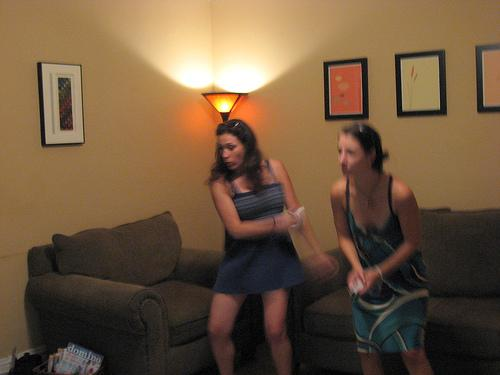Mention an accessory worn by the woman on the right and describe its placement on her. The woman on the right is wearing a bracelet on her arm. What kind of gaming device is being used by one of the women in the image? A woman is using a Wii video game controller. Describe the appearance of the couch and its position in the image. The couch is a dark brown color, positioned on the right side of the image. Explain the arrangement of framed pictures on the wall. There are three framed pictures in a row, each with different colors and patterns. What is the magazine called that is placed next to the armchair? The magazine is called "Domino". What is the color and style of the chair in the image? The chair is a dark brown, gray large armchair. Describe the position of the lamp in the image and its color. The lamp is positioned near the top left corner, with an orange lampshade. How would you describe the hairstyle and accessory worn by the woman in the blue dress? The woman in the blue dress has long dark brown hair and is wearing a shiny barrette. Identify the color and type of dress worn by the woman on the left. The woman on the left is wearing a blue dress with white lines on the skirt. What type of pillow can be found on the armchair? There is a large grey pillow on the armchair. 